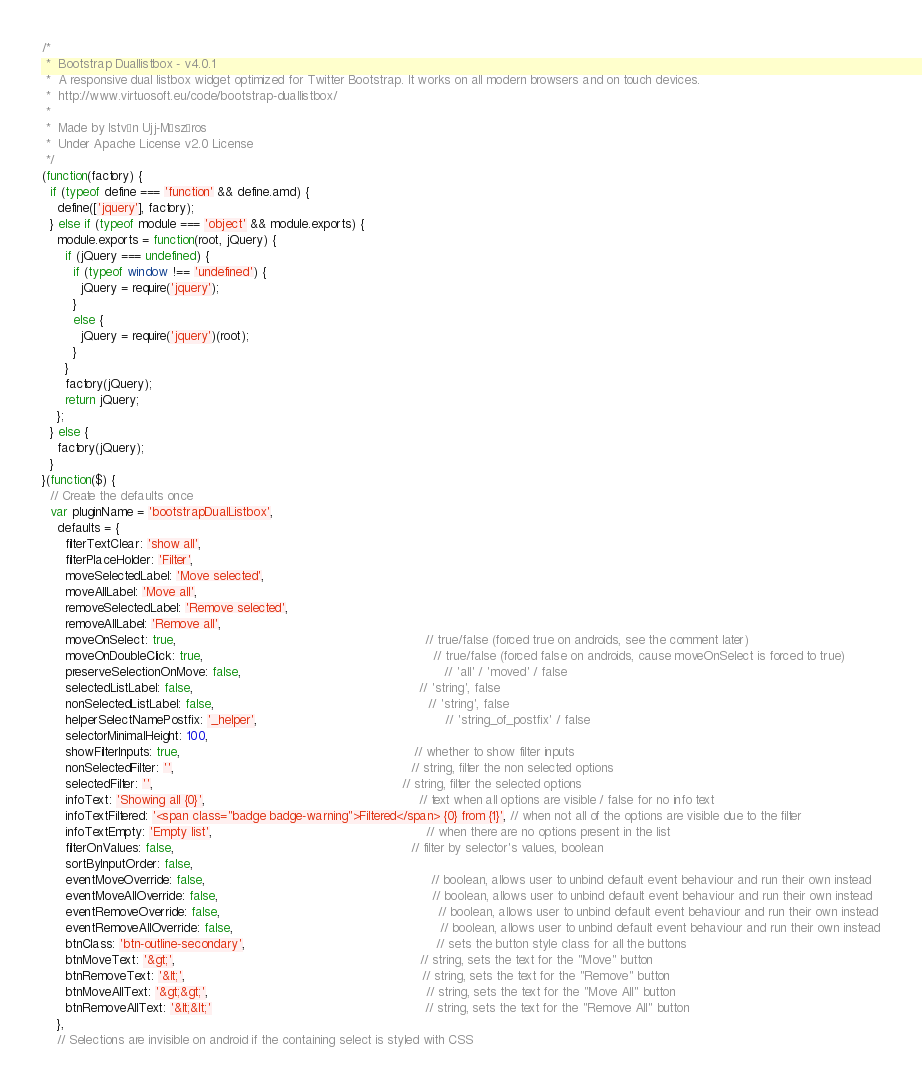Convert code to text. <code><loc_0><loc_0><loc_500><loc_500><_JavaScript_>/*
 *  Bootstrap Duallistbox - v4.0.1
 *  A responsive dual listbox widget optimized for Twitter Bootstrap. It works on all modern browsers and on touch devices.
 *  http://www.virtuosoft.eu/code/bootstrap-duallistbox/
 *
 *  Made by István Ujj-Mészáros
 *  Under Apache License v2.0 License
 */
(function(factory) {
  if (typeof define === 'function' && define.amd) {
    define(['jquery'], factory);
  } else if (typeof module === 'object' && module.exports) {
    module.exports = function(root, jQuery) {
      if (jQuery === undefined) {
        if (typeof window !== 'undefined') {
          jQuery = require('jquery');
        }
        else {
          jQuery = require('jquery')(root);
        }
      }
      factory(jQuery);
      return jQuery;
    };
  } else {
    factory(jQuery);
  }
}(function($) {
  // Create the defaults once
  var pluginName = 'bootstrapDualListbox',
    defaults = {
      filterTextClear: 'show all',
      filterPlaceHolder: 'Filter',
      moveSelectedLabel: 'Move selected',
      moveAllLabel: 'Move all',
      removeSelectedLabel: 'Remove selected',
      removeAllLabel: 'Remove all',
      moveOnSelect: true,                                                                 // true/false (forced true on androids, see the comment later)
      moveOnDoubleClick: true,                                                            // true/false (forced false on androids, cause moveOnSelect is forced to true)
      preserveSelectionOnMove: false,                                                     // 'all' / 'moved' / false
      selectedListLabel: false,                                                           // 'string', false
      nonSelectedListLabel: false,                                                        // 'string', false
      helperSelectNamePostfix: '_helper',                                                 // 'string_of_postfix' / false
      selectorMinimalHeight: 100,
      showFilterInputs: true,                                                             // whether to show filter inputs
      nonSelectedFilter: '',                                                              // string, filter the non selected options
      selectedFilter: '',                                                                 // string, filter the selected options
      infoText: 'Showing all {0}',                                                        // text when all options are visible / false for no info text
      infoTextFiltered: '<span class="badge badge-warning">Filtered</span> {0} from {1}', // when not all of the options are visible due to the filter
      infoTextEmpty: 'Empty list',                                                        // when there are no options present in the list
      filterOnValues: false,                                                              // filter by selector's values, boolean
      sortByInputOrder: false,
      eventMoveOverride: false,                                                           // boolean, allows user to unbind default event behaviour and run their own instead
      eventMoveAllOverride: false,                                                        // boolean, allows user to unbind default event behaviour and run their own instead
      eventRemoveOverride: false,                                                         // boolean, allows user to unbind default event behaviour and run their own instead
      eventRemoveAllOverride: false,                                                      // boolean, allows user to unbind default event behaviour and run their own instead
      btnClass: 'btn-outline-secondary',                                                  // sets the button style class for all the buttons
      btnMoveText: '&gt;',                                                                // string, sets the text for the "Move" button
      btnRemoveText: '&lt;',                                                              // string, sets the text for the "Remove" button
      btnMoveAllText: '&gt;&gt;',                                                         // string, sets the text for the "Move All" button
      btnRemoveAllText: '&lt;&lt;'                                                        // string, sets the text for the "Remove All" button
    },
    // Selections are invisible on android if the containing select is styled with CSS</code> 